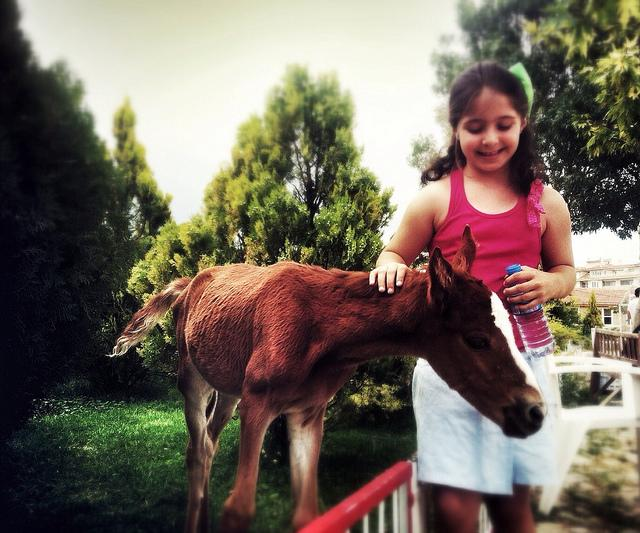What color is the cap on top of the water bottle held by the child? Please explain your reasoning. blue. The top cap of the water bottle is this color. 